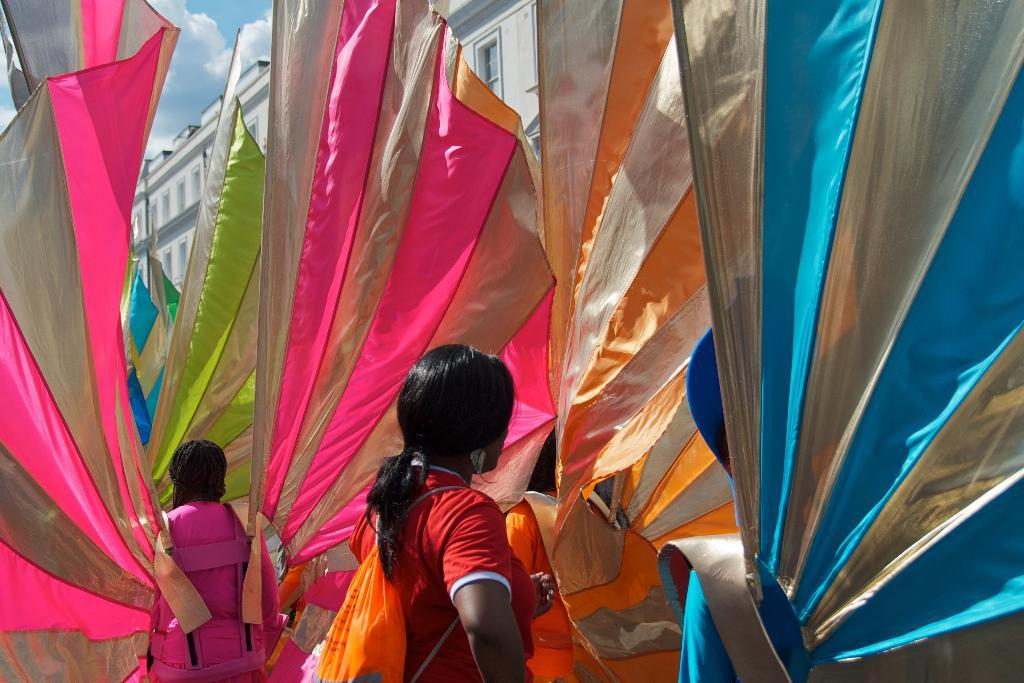What can be observed about the people in the image? There are people standing in the image, and they are wearing big wings. Can you describe the girl in the image? The girl in the image is wearing a backpack. What is located beside the people in the image? There is a building beside the people in the image. What is the reason for the people on the island to wear wings? There is no island present in the image, and the people are not wearing wings for any specific reason. 